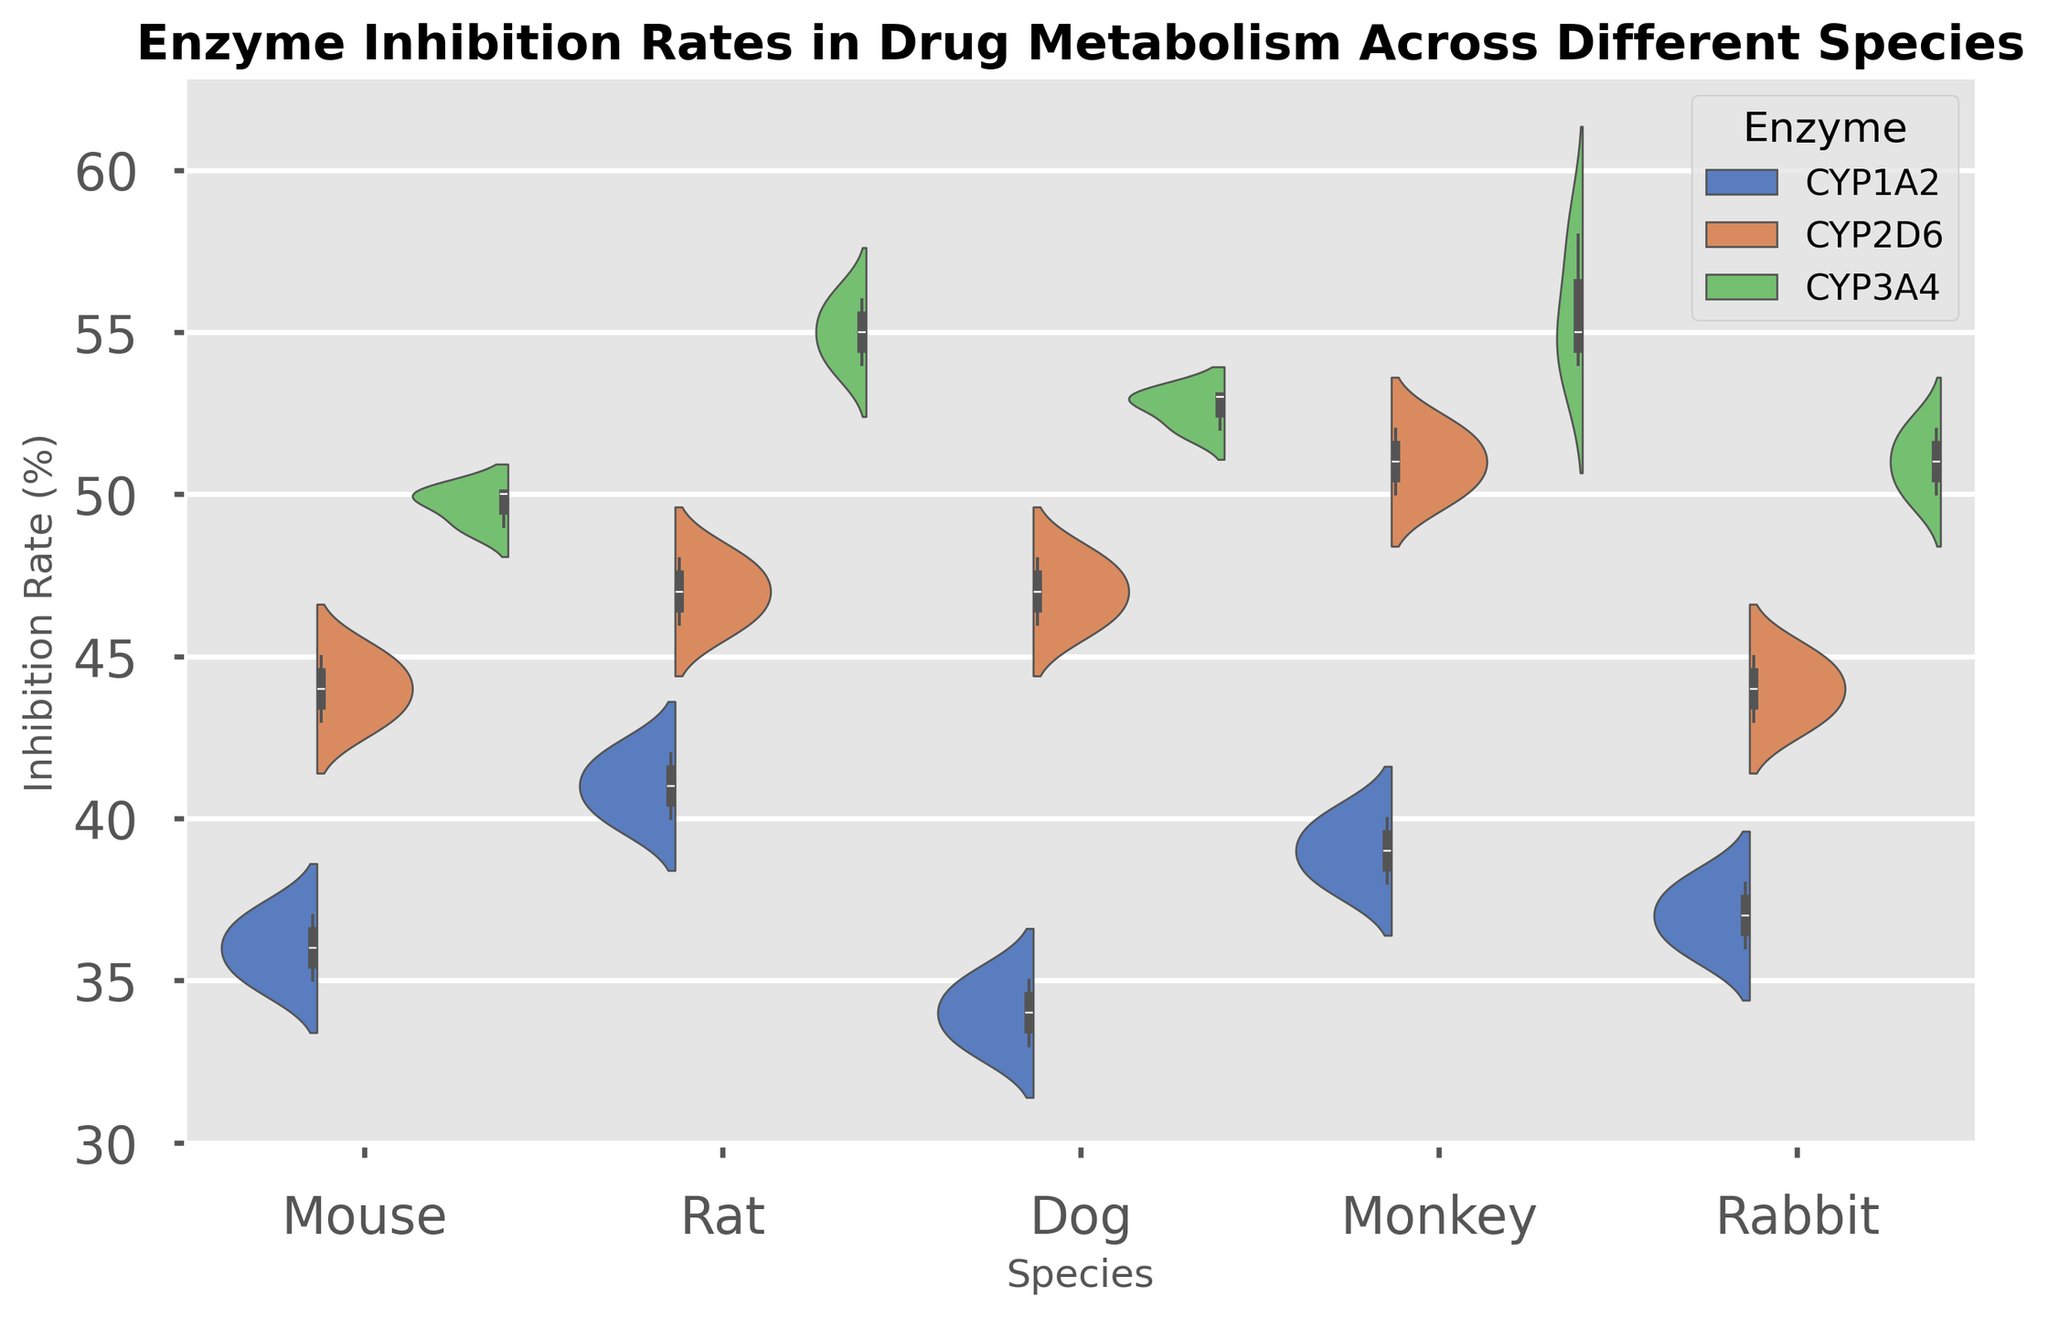What is the median inhibition rate for the enzyme CYP3A4 in the Mouse species? Look at the section of the violin plot corresponding to the Mouse species and CYP3A4 enzyme. The center white line in the violin plot represents the median value. Estimate the median by visually identifying the middle point.
Answer: 49% Which species shows the highest spread in inhibition rates for the enzyme CYP2D6? Compare the widths of the violin plots across the species for the enzyme CYP2D6. The species with the widest spread (tallest violin) has the highest spread in inhibition rates.
Answer: Monkey Are the median inhibition rates for the enzyme CYP1A2 similar across all species? Examine the median lines (white lines) in the sections corresponding to CYP1A2 for all species. Determine if the median values are visually close to each other.
Answer: Yes, they are similar Which species has the lowest inhibition rate for the enzyme CYP1A2? Look at the lowest points (bottom tails) of the violin plots corresponding to CYP1A2 enzyme across all species. Identify the species with the lowest point.
Answer: Dog Compare the average inhibition rates of CYP3A4 between Mouse and Rat species. Which one is higher? Estimate the average by looking at the general distribution (central tendency) of the violin plots for CYP3A4 in Mouse and Rat. Identify which appears to have a higher central tendency.
Answer: Rat Which species exhibits the least variation in inhibition rates for the enzyme CYP1A2? Examine the tightness (narrowness) of the violin plots corresponding to CYP1A2 across all species. The species with the narrowest violin plot exhibits the least variation.
Answer: Rabbit Are there significant differences in inhibition rates of CYP2D6 among the different species? Compare the overall distribution shapes (violin plots) for CYP2D6 among all species. Look for visual differences in spread and central tendency.
Answer: Yes, there are differences How does the inhibition rate of CYP1A2 in Dog compare to that of the Rabbit? Compare the height and shape of the violin plots for CYP1A2 corresponding to Dog and Rabbit. Look at both the median value and the overall distribution range.
Answer: The Rabbit's inhibition rate is slightly higher What is the visual difference between the distributions of enzyme inhibition rates for CYP3A4 in Mouse and Monkey? Look at the shape, spread, and median line of the violin plots for CYP3A4 in Mouse and Monkey. Visual differences may include width, symmetry, and central values.
Answer: Monkey has a broader distribution with a higher median Which enzyme shows the highest median inhibition rate in the Rat species? For the Rat species, compare the median lines (white lines) within each enzyme's section. The enzyme with the highest median line has the highest median inhibition rate.
Answer: CYP3A4 